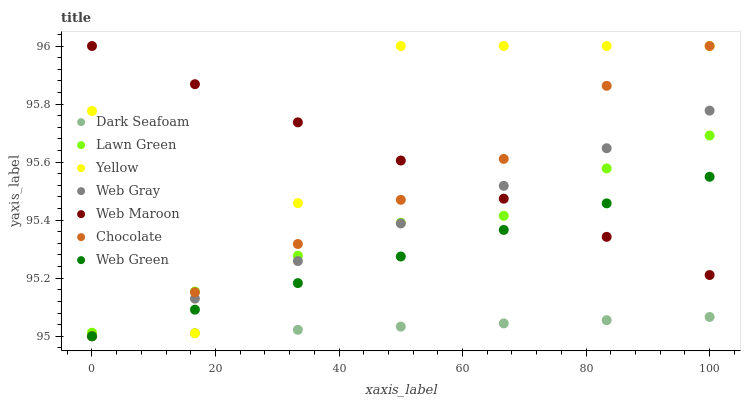Does Dark Seafoam have the minimum area under the curve?
Answer yes or no. Yes. Does Yellow have the maximum area under the curve?
Answer yes or no. Yes. Does Web Gray have the minimum area under the curve?
Answer yes or no. No. Does Web Gray have the maximum area under the curve?
Answer yes or no. No. Is Web Gray the smoothest?
Answer yes or no. Yes. Is Yellow the roughest?
Answer yes or no. Yes. Is Web Maroon the smoothest?
Answer yes or no. No. Is Web Maroon the roughest?
Answer yes or no. No. Does Web Gray have the lowest value?
Answer yes or no. Yes. Does Web Maroon have the lowest value?
Answer yes or no. No. Does Chocolate have the highest value?
Answer yes or no. Yes. Does Web Gray have the highest value?
Answer yes or no. No. Is Web Green less than Lawn Green?
Answer yes or no. Yes. Is Web Maroon greater than Dark Seafoam?
Answer yes or no. Yes. Does Chocolate intersect Web Green?
Answer yes or no. Yes. Is Chocolate less than Web Green?
Answer yes or no. No. Is Chocolate greater than Web Green?
Answer yes or no. No. Does Web Green intersect Lawn Green?
Answer yes or no. No. 